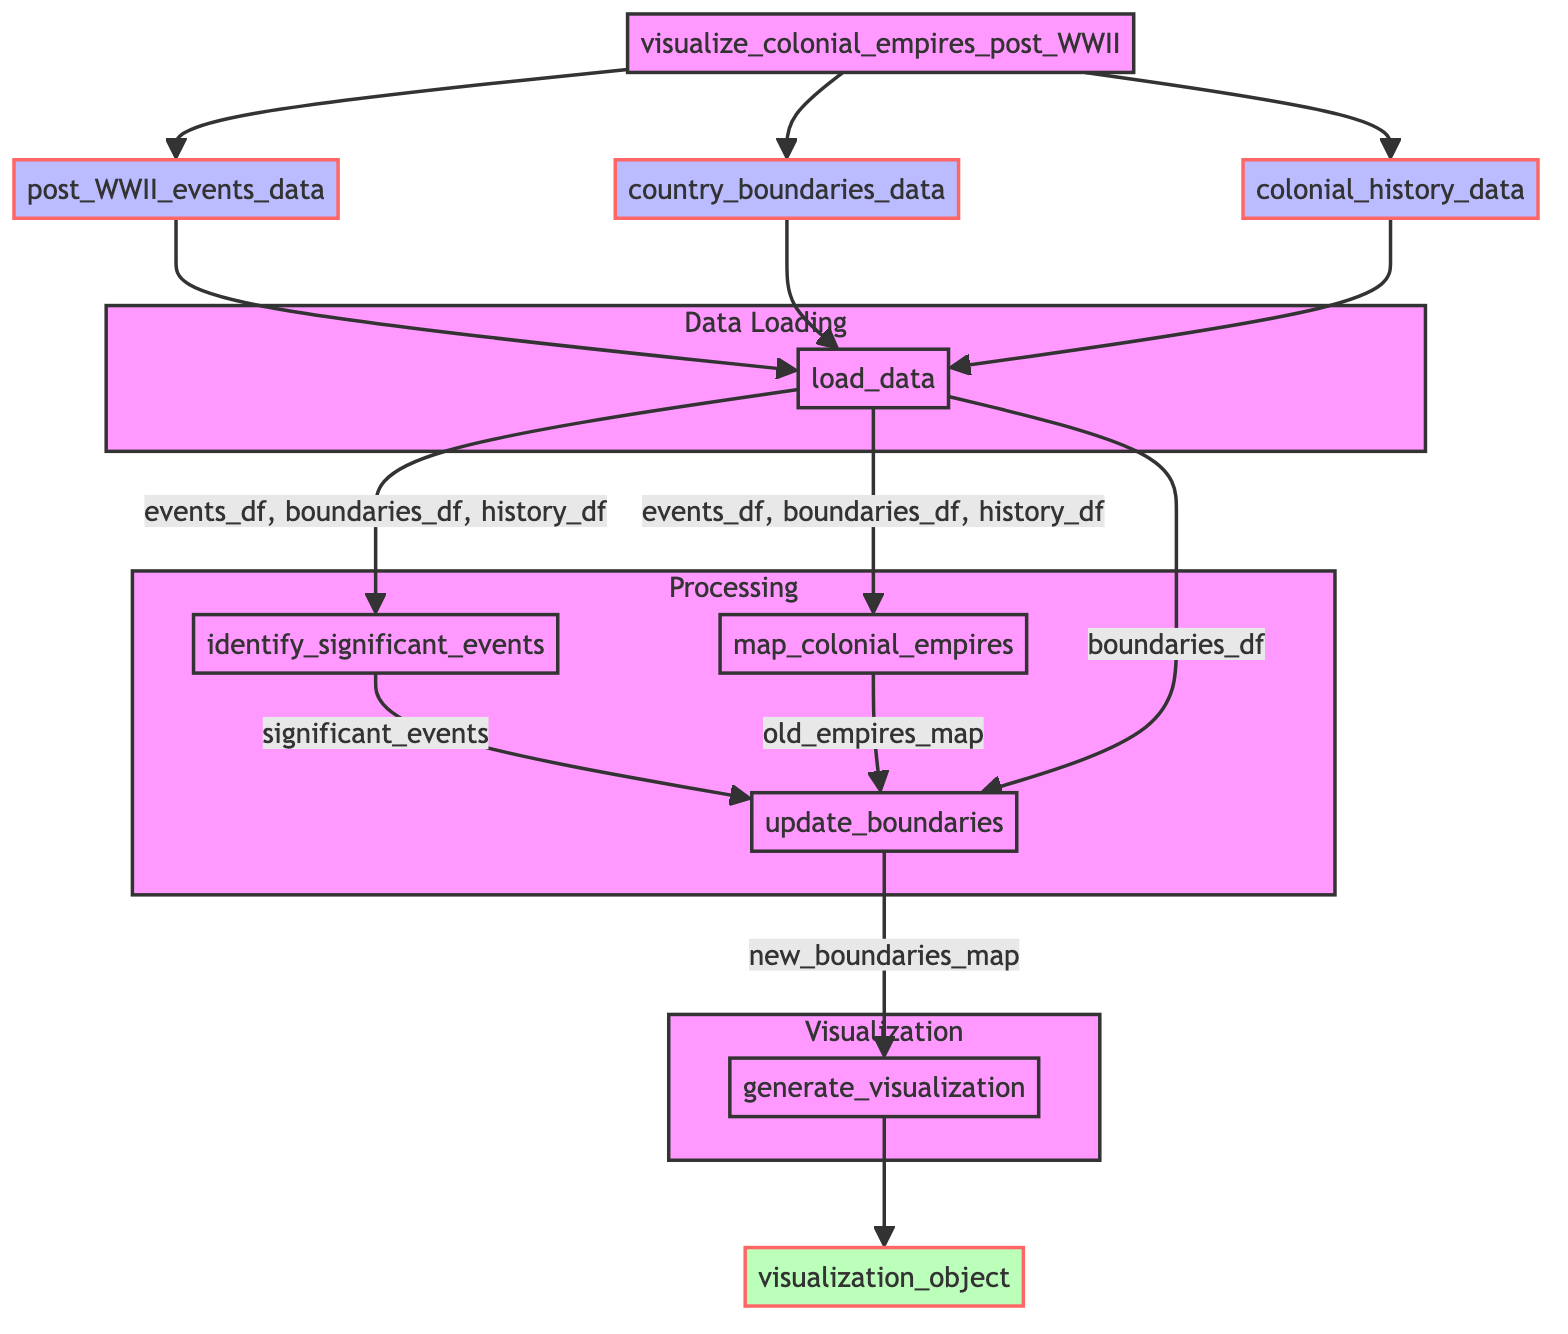What is the first step in the function? The first step in the function is 'Data Loading', where the function loads the datasets needed for processing. It specifically calls the 'load_data' function which takes three parameters.
Answer: Data Loading How many data inputs are required in total? There are three data inputs: post_WWII_events_data, country_boundaries_data, and colonial_history_data.
Answer: Three What is the output of the 'load_data' function? The 'load_data' function outputs three DataFrames: events_df, boundaries_df, and history_df, which are used in subsequent steps.
Answer: events_df, boundaries_df, history_df Which steps are part of the Processing subgraph? The Processing subgraph includes the steps 'Identify Significant Events', 'Map Old Colonial Empires', and 'Update Boundaries'. Each of these steps processes data leading towards the visualization.
Answer: Identify Significant Events, Map Old Colonial Empires, Update Boundaries What does the 'update_boundaries' function take as input parameters? The 'update_boundaries' function takes three input parameters: significant_events, old_empires_map, and boundaries_df. It uses these inputs to determine the new map of boundaries.
Answer: significant_events, old_empires_map, boundaries_df How many outputs does the diagram indicate? The diagram indicates a single output, which is the 'visualization_object' resulting from the 'generate_visualization' step.
Answer: One What function generates the final visualization? The final visualization is generated by the 'generate_visualization' function, which takes the new boundaries map as input and outputs the visualization object.
Answer: generate_visualization Which function identifies the significant events from the dataset? The function that identifies the significant events is 'identify_significant_events', which uses the events DataFrame as its parameter to extract important occurrences.
Answer: identify_significant_events What are the outputs of the 'update_boundaries' step? The 'update_boundaries' step outputs the 'new_boundaries_map', which is crucial for the subsequent visualization generation step.
Answer: new_boundaries_map 